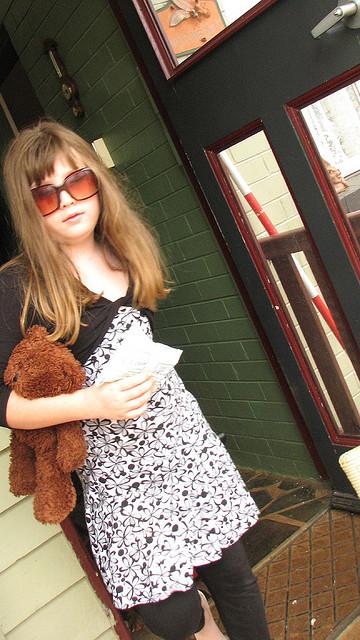What color pants is the woman wearing?
Give a very brief answer. Black. What is the brown object the woman is holding?
Give a very brief answer. Teddy bear. Is the woman wearing glasses?
Be succinct. Yes. 